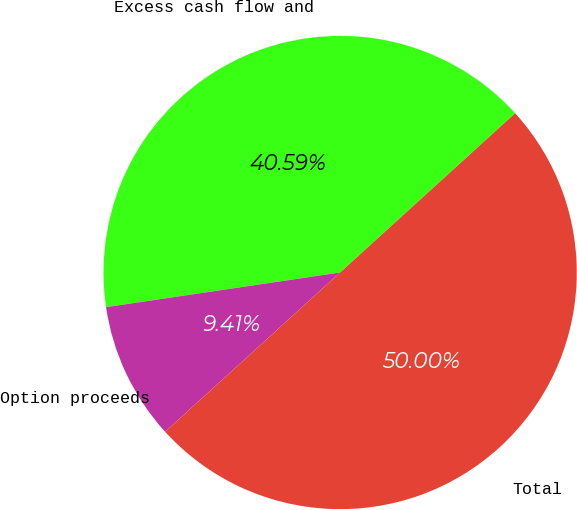<chart> <loc_0><loc_0><loc_500><loc_500><pie_chart><fcel>Excess cash flow and<fcel>Option proceeds<fcel>Total<nl><fcel>40.59%<fcel>9.41%<fcel>50.0%<nl></chart> 